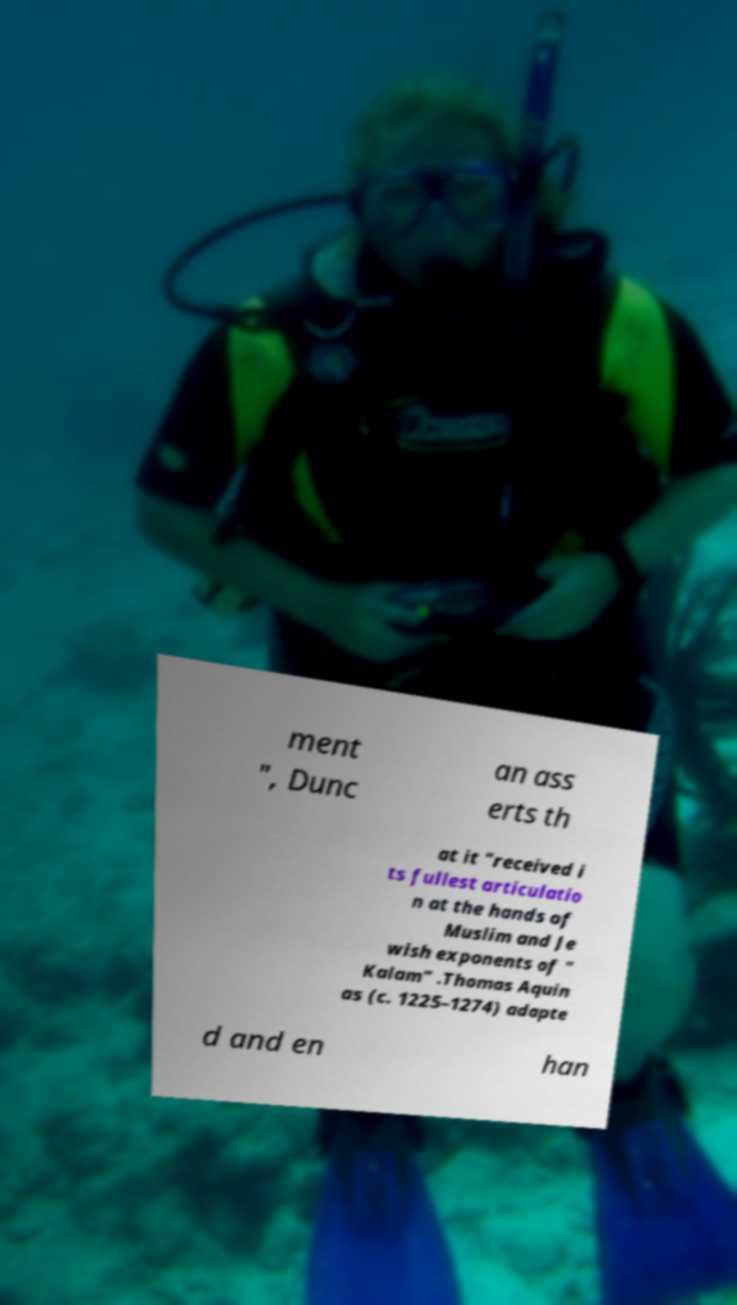Could you assist in decoding the text presented in this image and type it out clearly? ment ", Dunc an ass erts th at it "received i ts fullest articulatio n at the hands of Muslim and Je wish exponents of " Kalam" .Thomas Aquin as (c. 1225–1274) adapte d and en han 